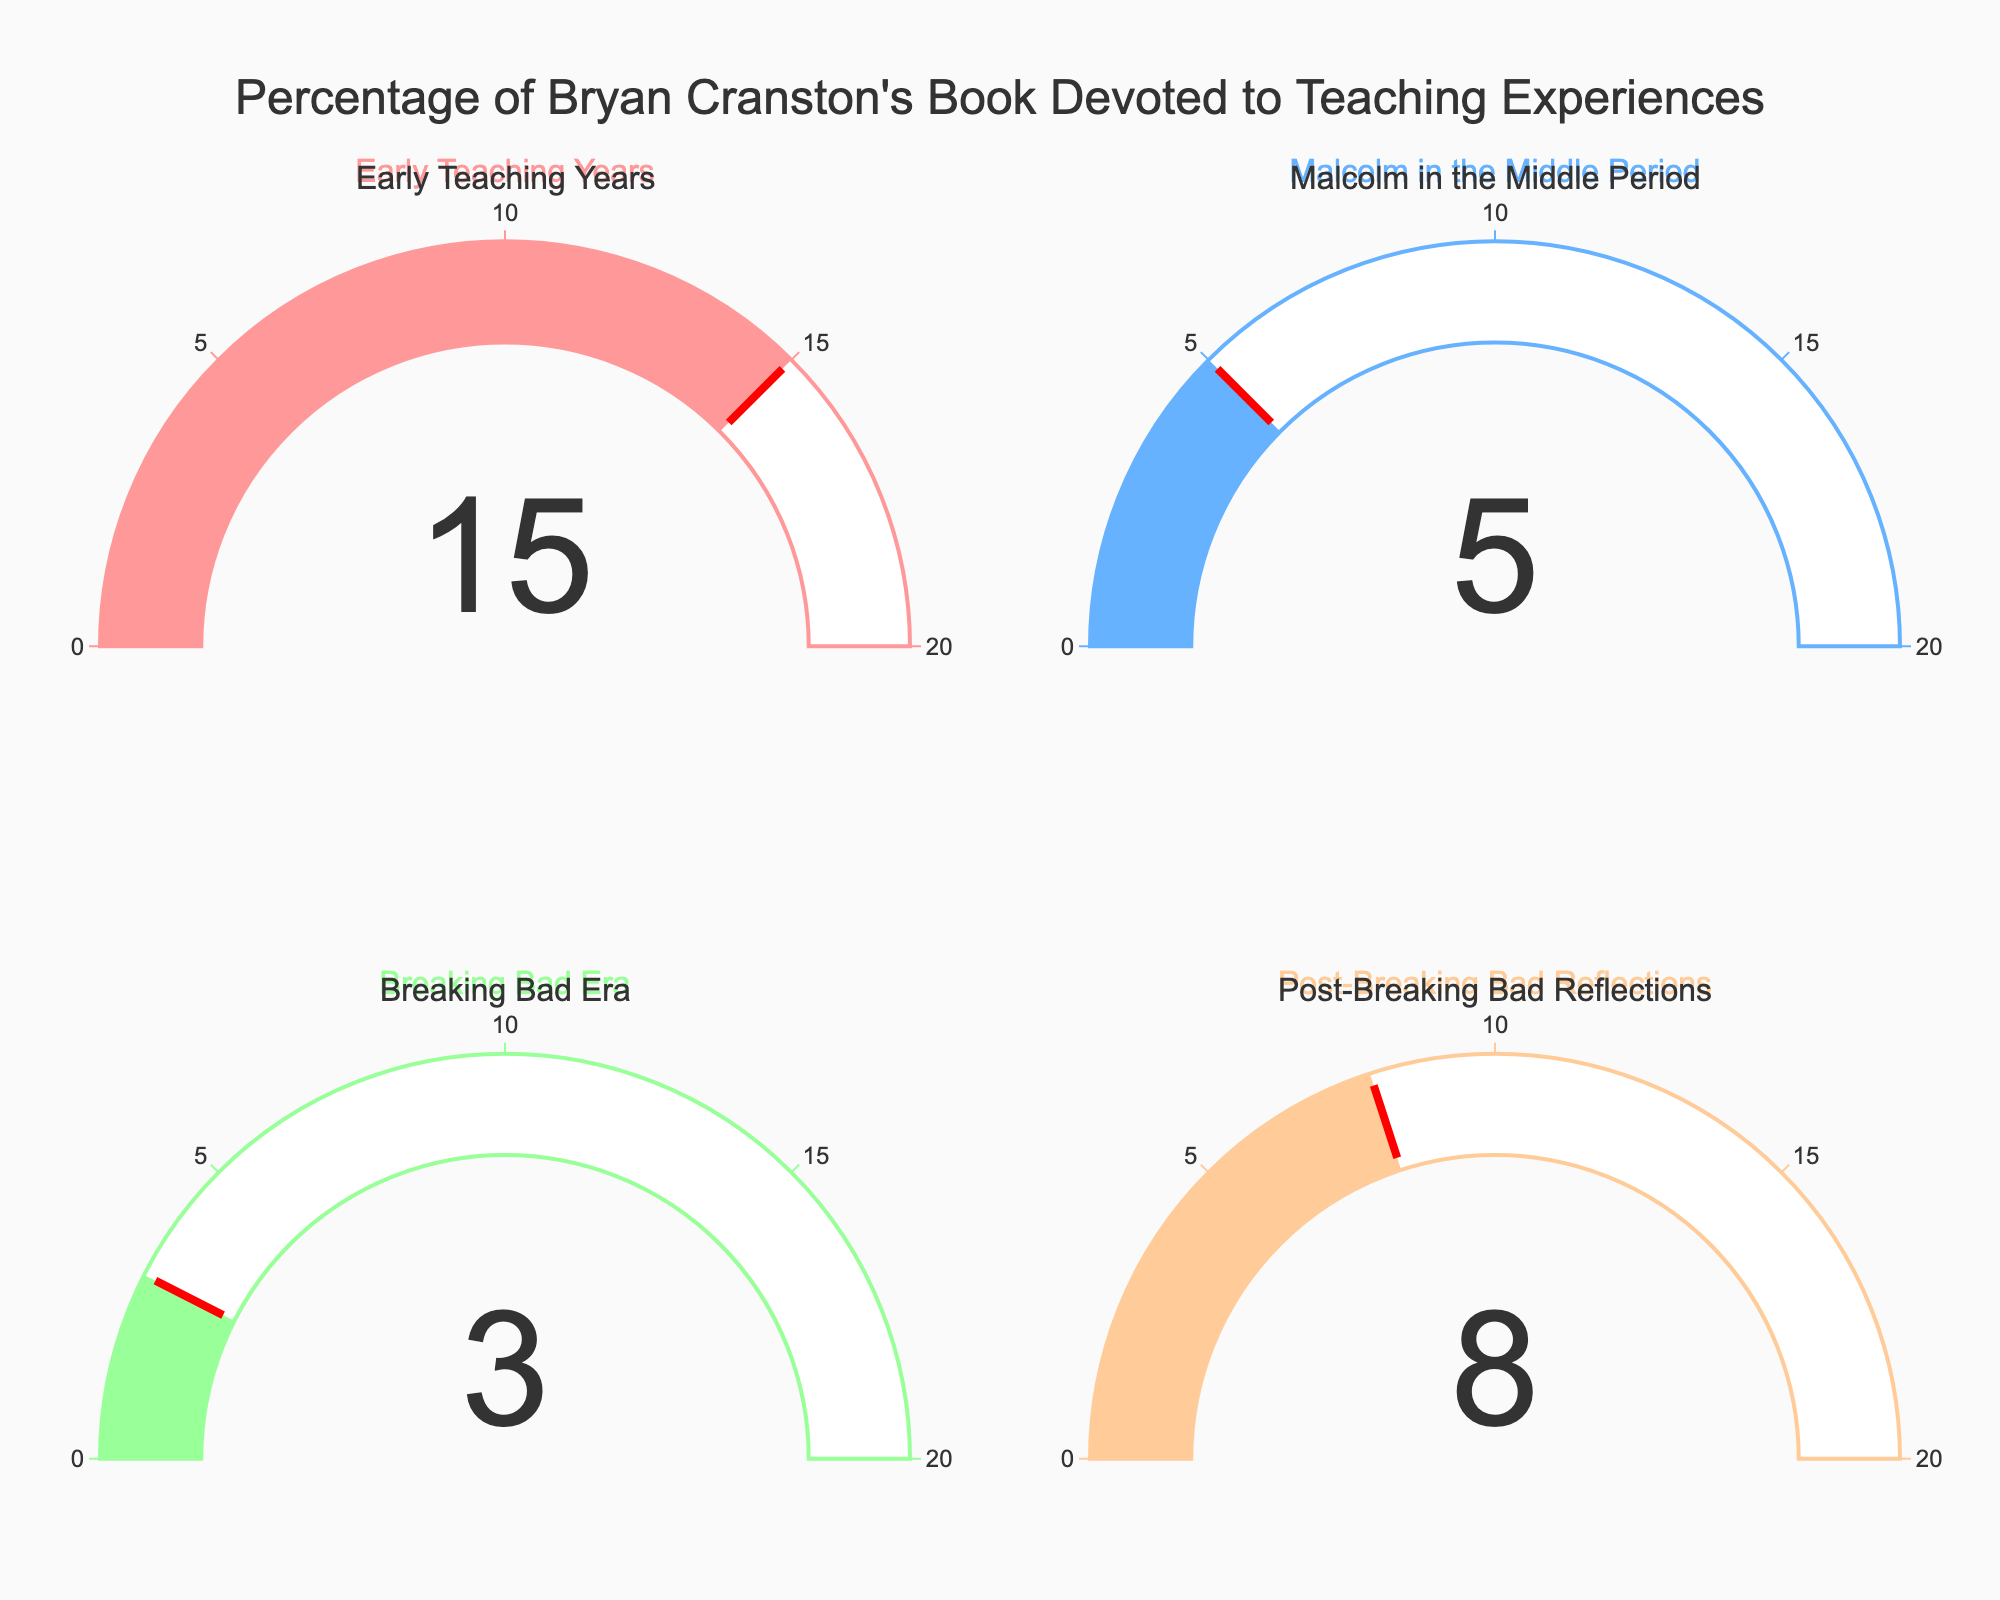What's the highest percentage of Bryan Cranston's book devoted to a teaching period? By looking at the gauge chart, identify the gauge with the highest number. The Early Teaching Years gauge shows 15%, which is the highest.
Answer: 15% What's the lowest percentage of Bryan Cranston's book devoted to a teaching period? By looking at the gauge chart, identify the gauge with the lowest number. The Breaking Bad Era gauge shows 3%, which is the lowest.
Answer: 3% What is the combined percentage of the book devoted to Early Teaching Years and Malcolm in the Middle Period? Add the percentages shown for Early Teaching Years and Malcolm in the Middle Period, which are 15% and 5% respectively. 15% + 5% = 20%
Answer: 20% How much more percentage of the book is devoted to Early Teaching Years compared to Post-Breaking Bad Reflections? Subtract the percentage for Post-Breaking Bad Reflections from the percentage for Early Teaching Years. 15% - 8% = 7%
Answer: 7% What is the total percentage of the book discussing Malcolm in the Middle Period and Breaking Bad Era combined? Add the percentages shown for Malcolm in the Middle Period and Breaking Bad Era, which are 5% and 3% respectively. 5% + 3% = 8%
Answer: 8% Which teaching period has a gauge value less than 10%? Identify the gauges with values less than 10%. The gauges for Malcolm in the Middle Period and Breaking Bad Era are less than 10%, showing 5% and 3% respectively.
Answer: Malcolm in the Middle Period and Breaking Bad Era How does the percentage devoted to Post-Breaking Bad Reflections compare to that devoted to Malcolm in the Middle Period? Compare the two percentages directly. Post-Breaking Bad Reflections has 8%, which is higher than the 5% for Malcolm in the Middle Period.
Answer: Post-Breaking Bad Reflections is higher What is the average percentage of the four teaching periods featured in the book? Add all the provided percentages (15%, 5%, 3%, 8%) and divide by the number of periods (4). (15% + 5% + 3% + 8%) / 4 = 31% / 4 = 7.75%
Answer: 7.75% 